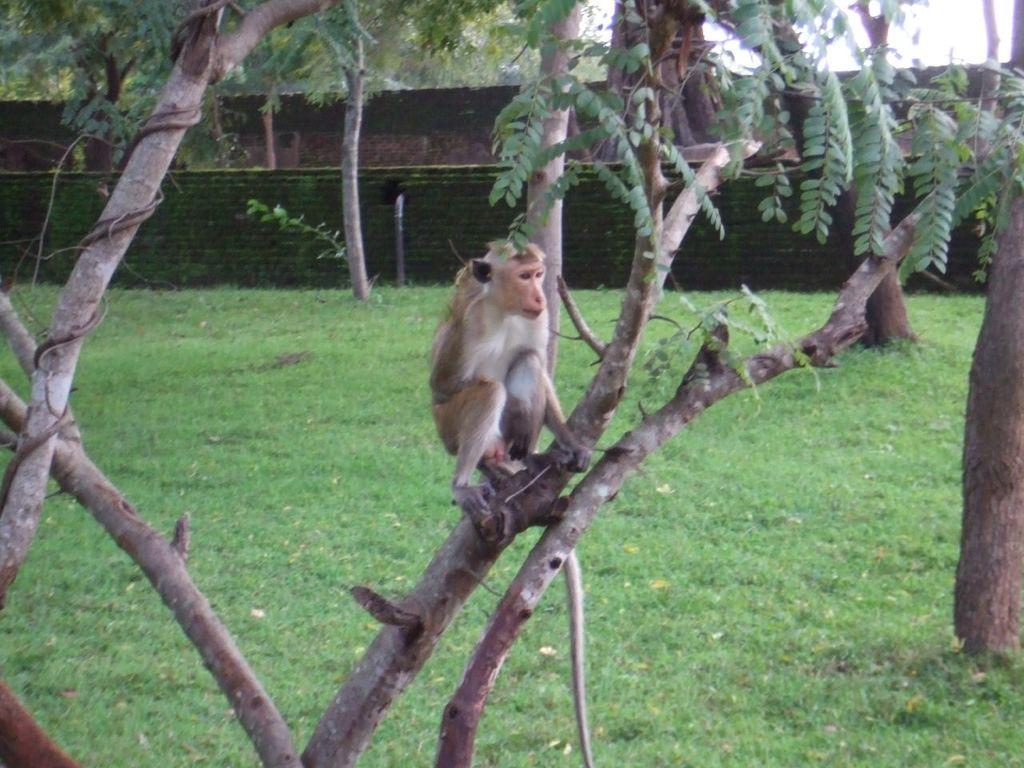What animal is present in the image? There is a monkey in the image. Where is the monkey located? The monkey is sitting on a tree. What type of vegetation can be seen in the image? There is grass in the image. What structures are visible in the background of the image? There is a wall and a fence in the background of the image. What form does the monkey take in the image? The monkey is depicted in its natural form, as an animal, and there is no indication of any transformation or change in form. 